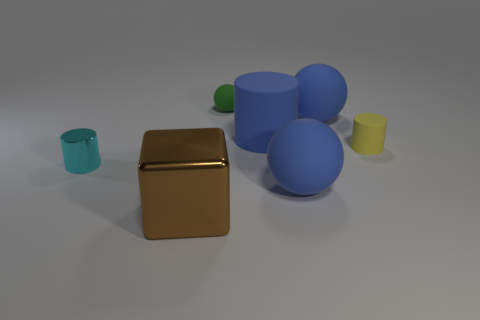Add 2 blocks. How many objects exist? 9 Subtract all cylinders. How many objects are left? 4 Add 7 big brown things. How many big brown things are left? 8 Add 3 tiny green rubber objects. How many tiny green rubber objects exist? 4 Subtract 0 gray blocks. How many objects are left? 7 Subtract all big green matte cylinders. Subtract all large blue rubber spheres. How many objects are left? 5 